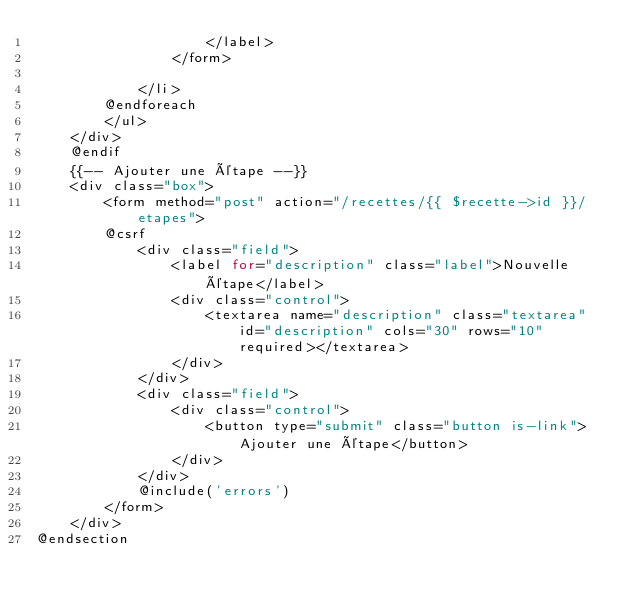<code> <loc_0><loc_0><loc_500><loc_500><_PHP_>                    </label>
                </form>
                
            </li>
        @endforeach
        </ul>
    </div>
    @endif
    {{-- Ajouter une étape --}}
    <div class="box">
        <form method="post" action="/recettes/{{ $recette->id }}/etapes">
        @csrf
            <div class="field">
                <label for="description" class="label">Nouvelle étape</label>
                <div class="control">
                    <textarea name="description" class="textarea" id="description" cols="30" rows="10" required></textarea>
                </div>
            </div>
            <div class="field">
                <div class="control">
                    <button type="submit" class="button is-link">Ajouter une étape</button>
                </div>
            </div>
            @include('errors')
        </form>
    </div>
@endsection</code> 